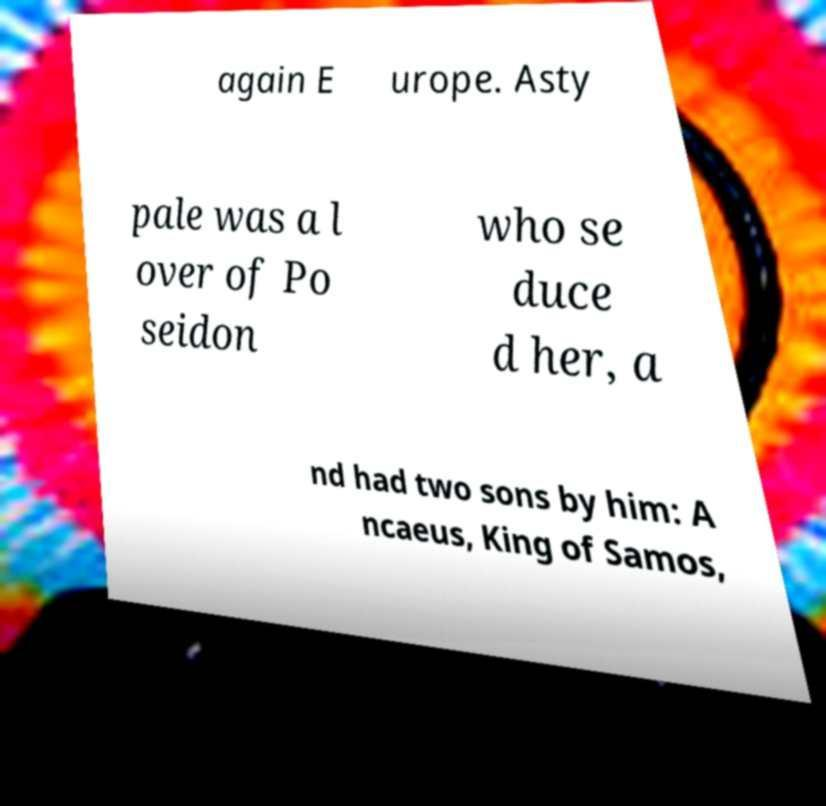Can you accurately transcribe the text from the provided image for me? again E urope. Asty pale was a l over of Po seidon who se duce d her, a nd had two sons by him: A ncaeus, King of Samos, 